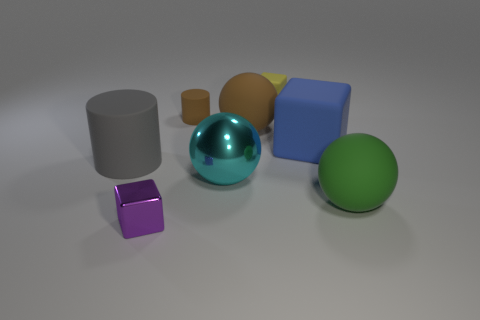Add 2 big cyan matte blocks. How many objects exist? 10 Subtract all cubes. How many objects are left? 5 Subtract all red matte cubes. Subtract all large rubber objects. How many objects are left? 4 Add 5 small brown things. How many small brown things are left? 6 Add 2 large green things. How many large green things exist? 3 Subtract 0 red blocks. How many objects are left? 8 